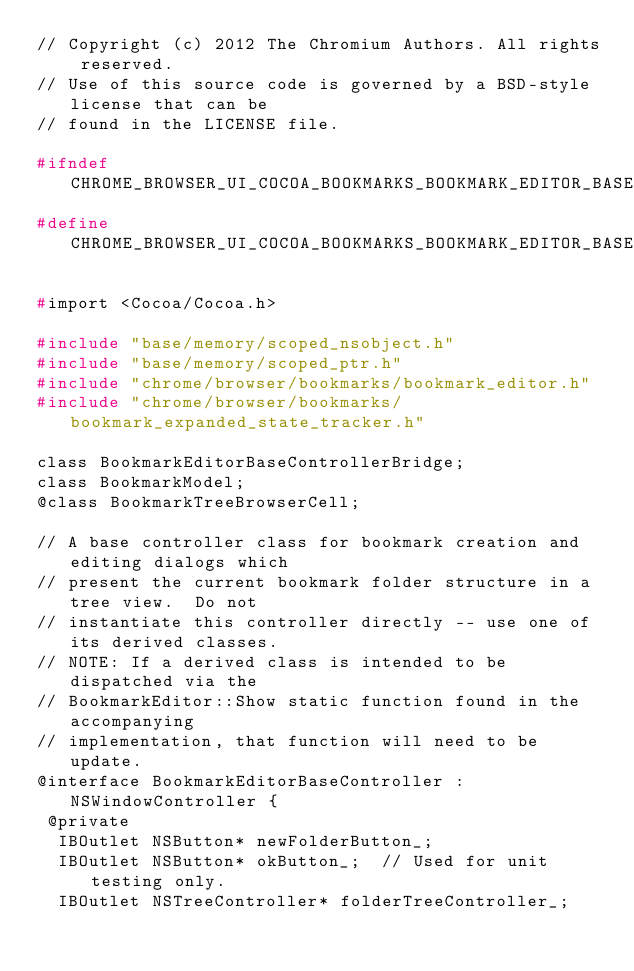Convert code to text. <code><loc_0><loc_0><loc_500><loc_500><_C_>// Copyright (c) 2012 The Chromium Authors. All rights reserved.
// Use of this source code is governed by a BSD-style license that can be
// found in the LICENSE file.

#ifndef CHROME_BROWSER_UI_COCOA_BOOKMARKS_BOOKMARK_EDITOR_BASE_CONTROLLER_H_
#define CHROME_BROWSER_UI_COCOA_BOOKMARKS_BOOKMARK_EDITOR_BASE_CONTROLLER_H_

#import <Cocoa/Cocoa.h>

#include "base/memory/scoped_nsobject.h"
#include "base/memory/scoped_ptr.h"
#include "chrome/browser/bookmarks/bookmark_editor.h"
#include "chrome/browser/bookmarks/bookmark_expanded_state_tracker.h"

class BookmarkEditorBaseControllerBridge;
class BookmarkModel;
@class BookmarkTreeBrowserCell;

// A base controller class for bookmark creation and editing dialogs which
// present the current bookmark folder structure in a tree view.  Do not
// instantiate this controller directly -- use one of its derived classes.
// NOTE: If a derived class is intended to be dispatched via the
// BookmarkEditor::Show static function found in the accompanying
// implementation, that function will need to be update.
@interface BookmarkEditorBaseController : NSWindowController {
 @private
  IBOutlet NSButton* newFolderButton_;
  IBOutlet NSButton* okButton_;  // Used for unit testing only.
  IBOutlet NSTreeController* folderTreeController_;</code> 